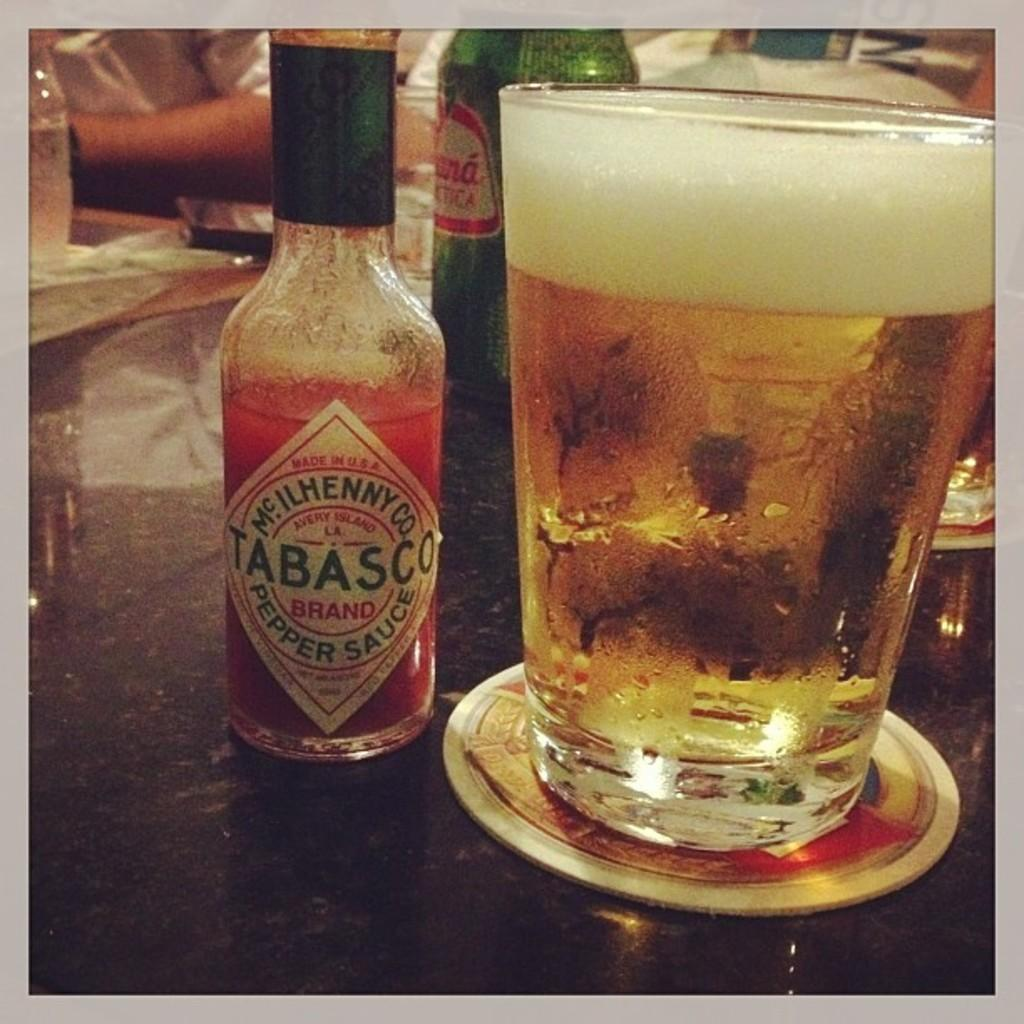What objects can be seen in the image? There are bottles and a glass with a drink in the image. Can you describe the people in the background of the image? There is no specific description of the people in the background, but they are present. What is on the floor in the background of the image? There is cloth on the floor in the background of the image. What suggestion does the finger in the image make? There is no finger present in the image, so no suggestion can be made. 